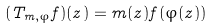<formula> <loc_0><loc_0><loc_500><loc_500>( T _ { m , \varphi } f ) ( z ) = m ( z ) f ( \varphi ( z ) )</formula> 